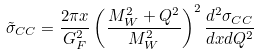Convert formula to latex. <formula><loc_0><loc_0><loc_500><loc_500>\tilde { \sigma } _ { C C } = \frac { 2 \pi x } { G _ { F } ^ { 2 } } \left ( \frac { M _ { W } ^ { 2 } + Q ^ { 2 } } { M _ { W } ^ { 2 } } \right ) ^ { 2 } \frac { d ^ { 2 } \sigma _ { C C } } { d x d Q ^ { 2 } }</formula> 